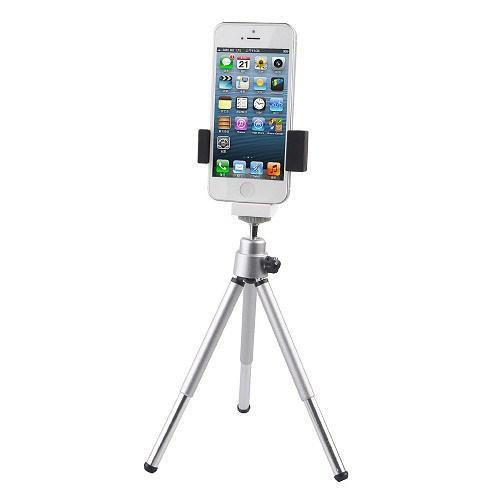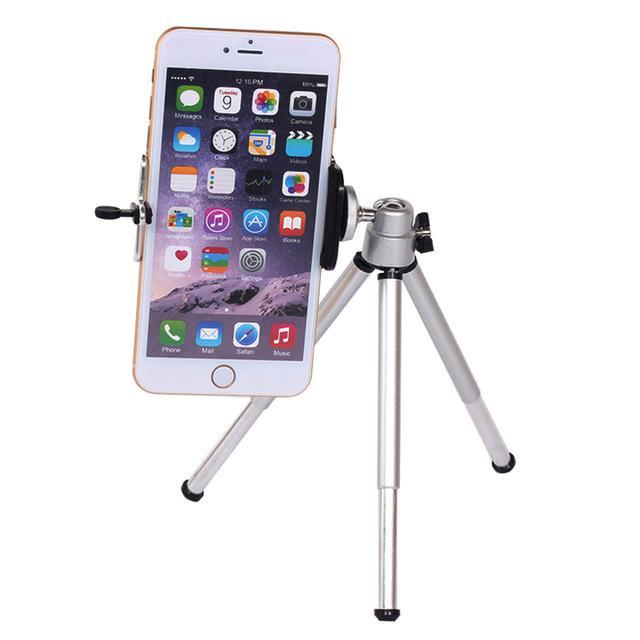The first image is the image on the left, the second image is the image on the right. Assess this claim about the two images: "The back of a phone is visible.". Correct or not? Answer yes or no. No. The first image is the image on the left, the second image is the image on the right. Analyze the images presented: Is the assertion "There is a total of three cell phones." valid? Answer yes or no. No. 